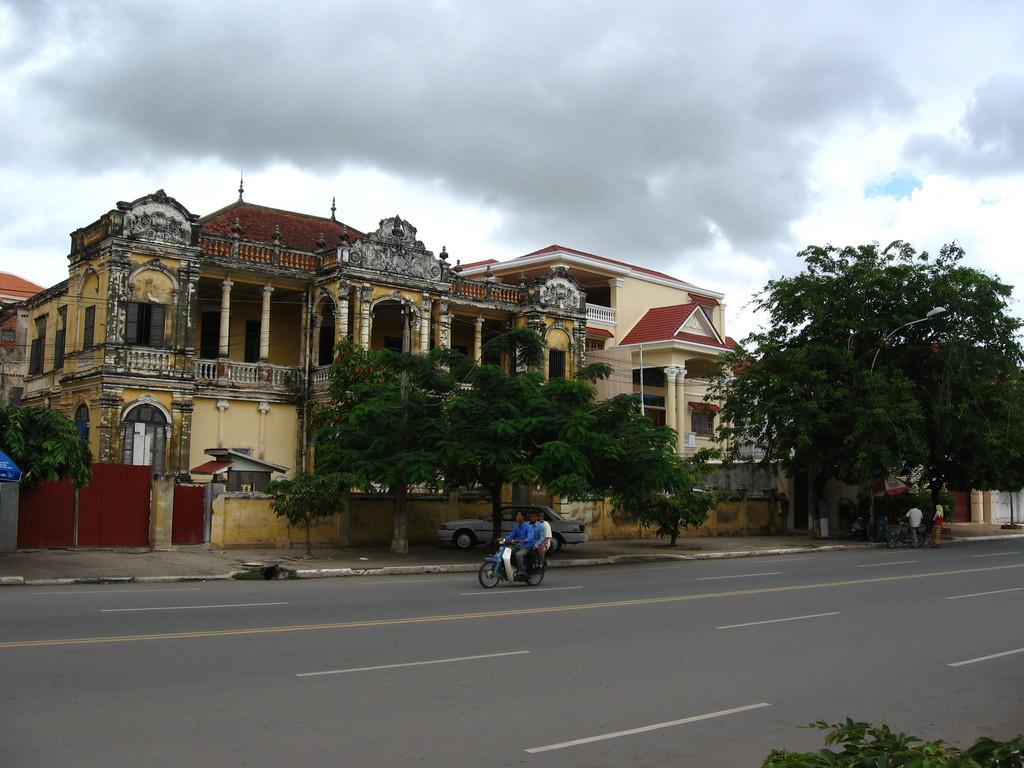How would you summarize this image in a sentence or two? In this picture we can observe three persons on the bike. The bike is on the road. We can observe trees and buildings. In the background there is a sky with some clouds. 